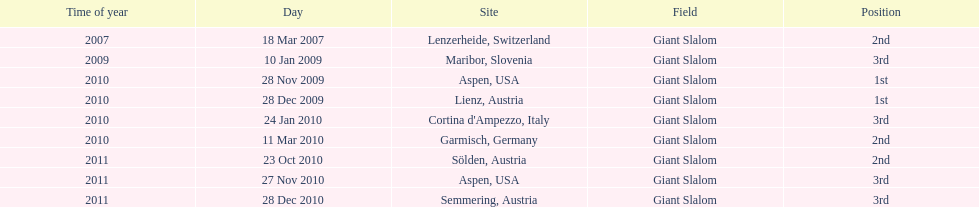What is the only location in the us? Aspen. 